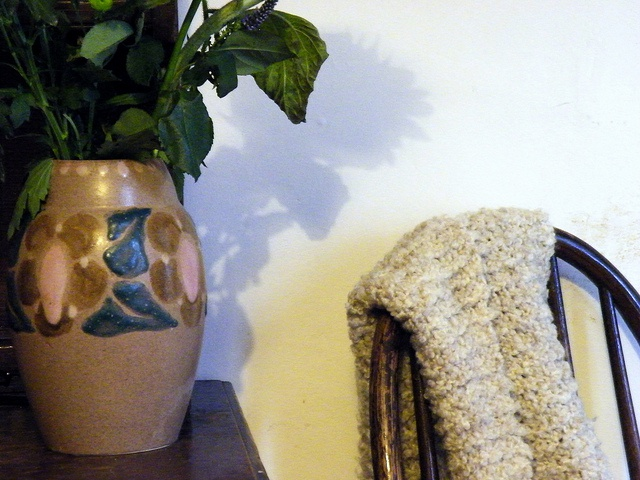Describe the objects in this image and their specific colors. I can see potted plant in lightgray, black, olive, and gray tones, vase in black, gray, and maroon tones, and chair in black, lightgray, tan, and olive tones in this image. 